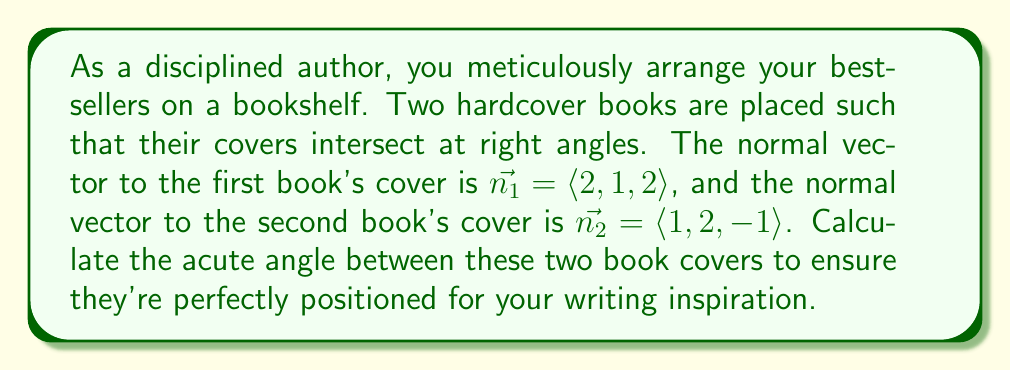Can you answer this question? To find the angle between two intersecting planes, we can use the formula:

$$\cos \theta = \frac{|\vec{n_1} \cdot \vec{n_2}|}{\|\vec{n_1}\| \|\vec{n_2}\|}$$

Where $\vec{n_1}$ and $\vec{n_2}$ are the normal vectors to the planes, $\cdot$ represents the dot product, and $\|\vec{n}\|$ represents the magnitude of a vector.

Step 1: Calculate the dot product of $\vec{n_1}$ and $\vec{n_2}$:
$$\vec{n_1} \cdot \vec{n_2} = (2)(1) + (1)(2) + (2)(-1) = 2 + 2 - 2 = 2$$

Step 2: Calculate the magnitudes of $\vec{n_1}$ and $\vec{n_2}$:
$$\|\vec{n_1}\| = \sqrt{2^2 + 1^2 + 2^2} = \sqrt{9} = 3$$
$$\|\vec{n_2}\| = \sqrt{1^2 + 2^2 + (-1)^2} = \sqrt{6}$$

Step 3: Apply the formula:
$$\cos \theta = \frac{|2|}{3\sqrt{6}} = \frac{2}{3\sqrt{6}}$$

Step 4: Take the inverse cosine (arccos) of both sides:
$$\theta = \arccos\left(\frac{2}{3\sqrt{6}}\right)$$

Step 5: Calculate the result (rounded to two decimal places):
$$\theta \approx 1.27 \text{ radians} \approx 72.45°$$
Answer: The acute angle between the two book covers is approximately 72.45°. 